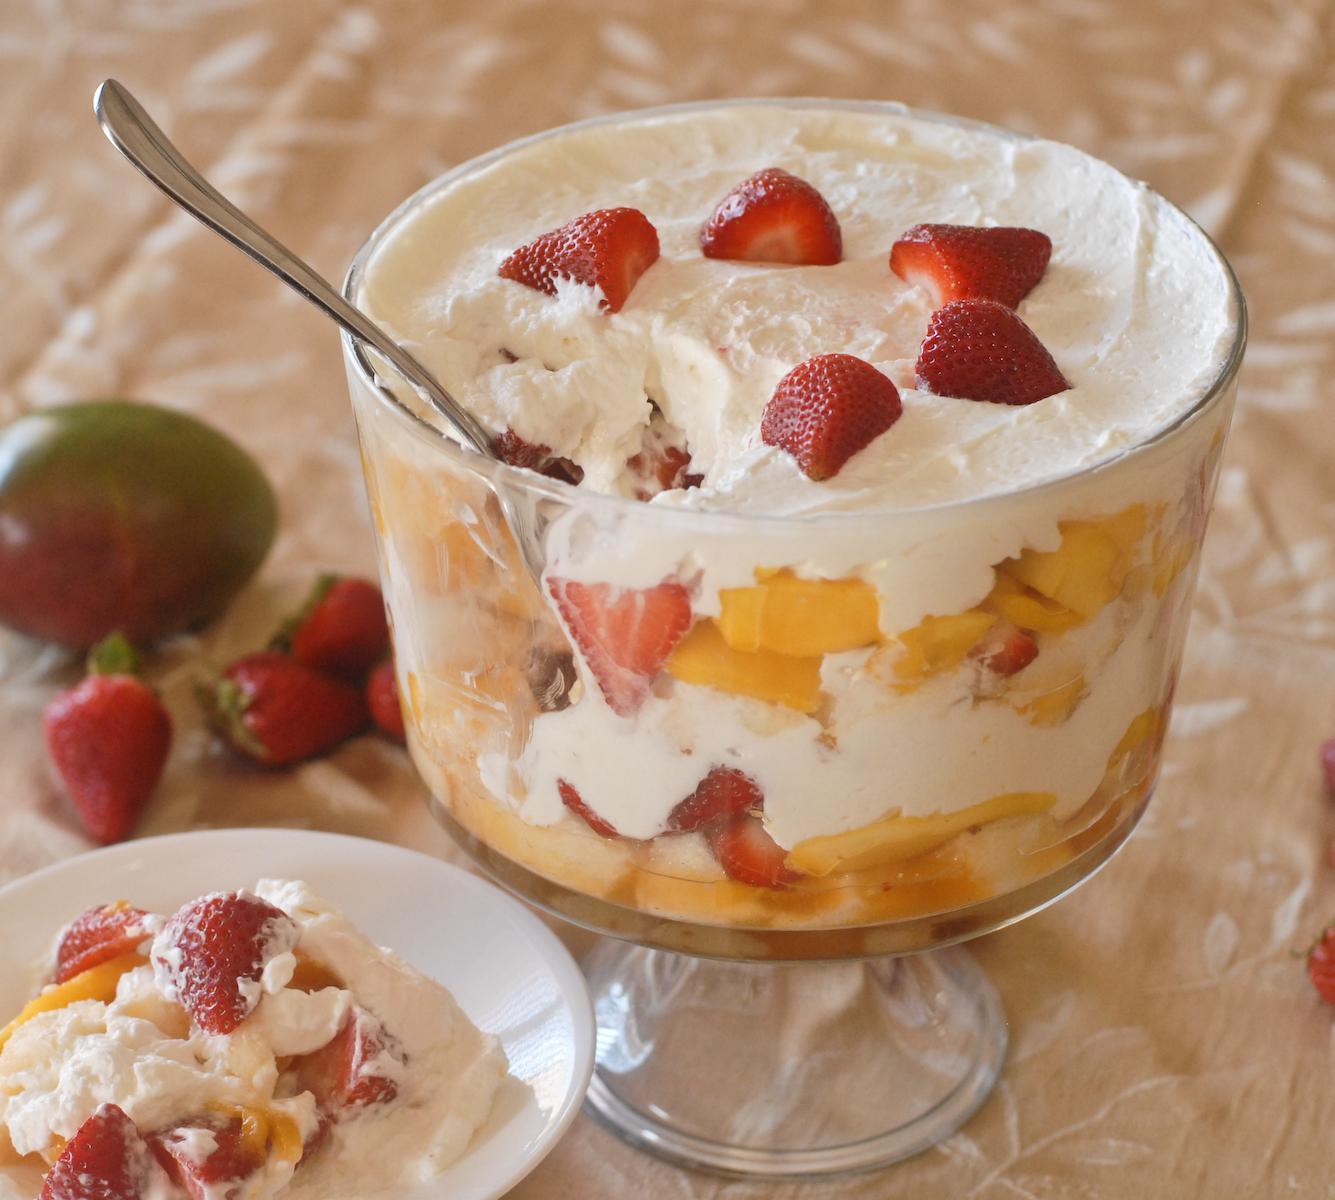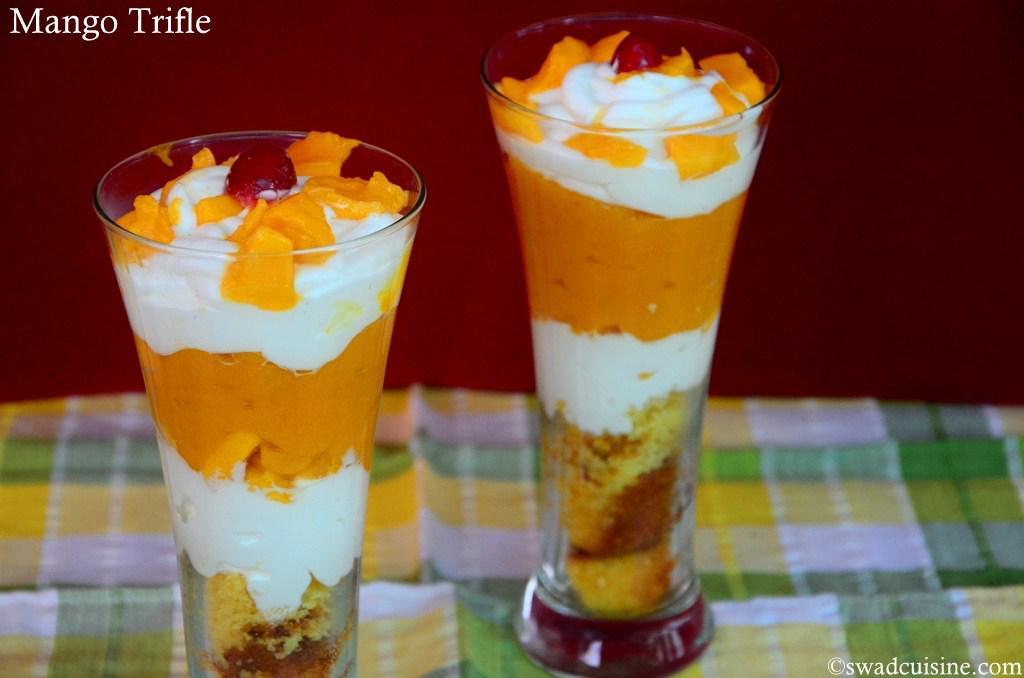The first image is the image on the left, the second image is the image on the right. Assess this claim about the two images: "there are 2 parfaits on the right image". Correct or not? Answer yes or no. Yes. 